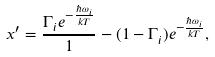Convert formula to latex. <formula><loc_0><loc_0><loc_500><loc_500>x ^ { \prime } = \frac { \Gamma _ { i } e ^ { - \frac { \hbar { \omega } _ { i } } { k T } } } 1 - ( 1 - \Gamma _ { i } ) e ^ { - \frac { \hbar { \omega } _ { i } } { k T } } ,</formula> 